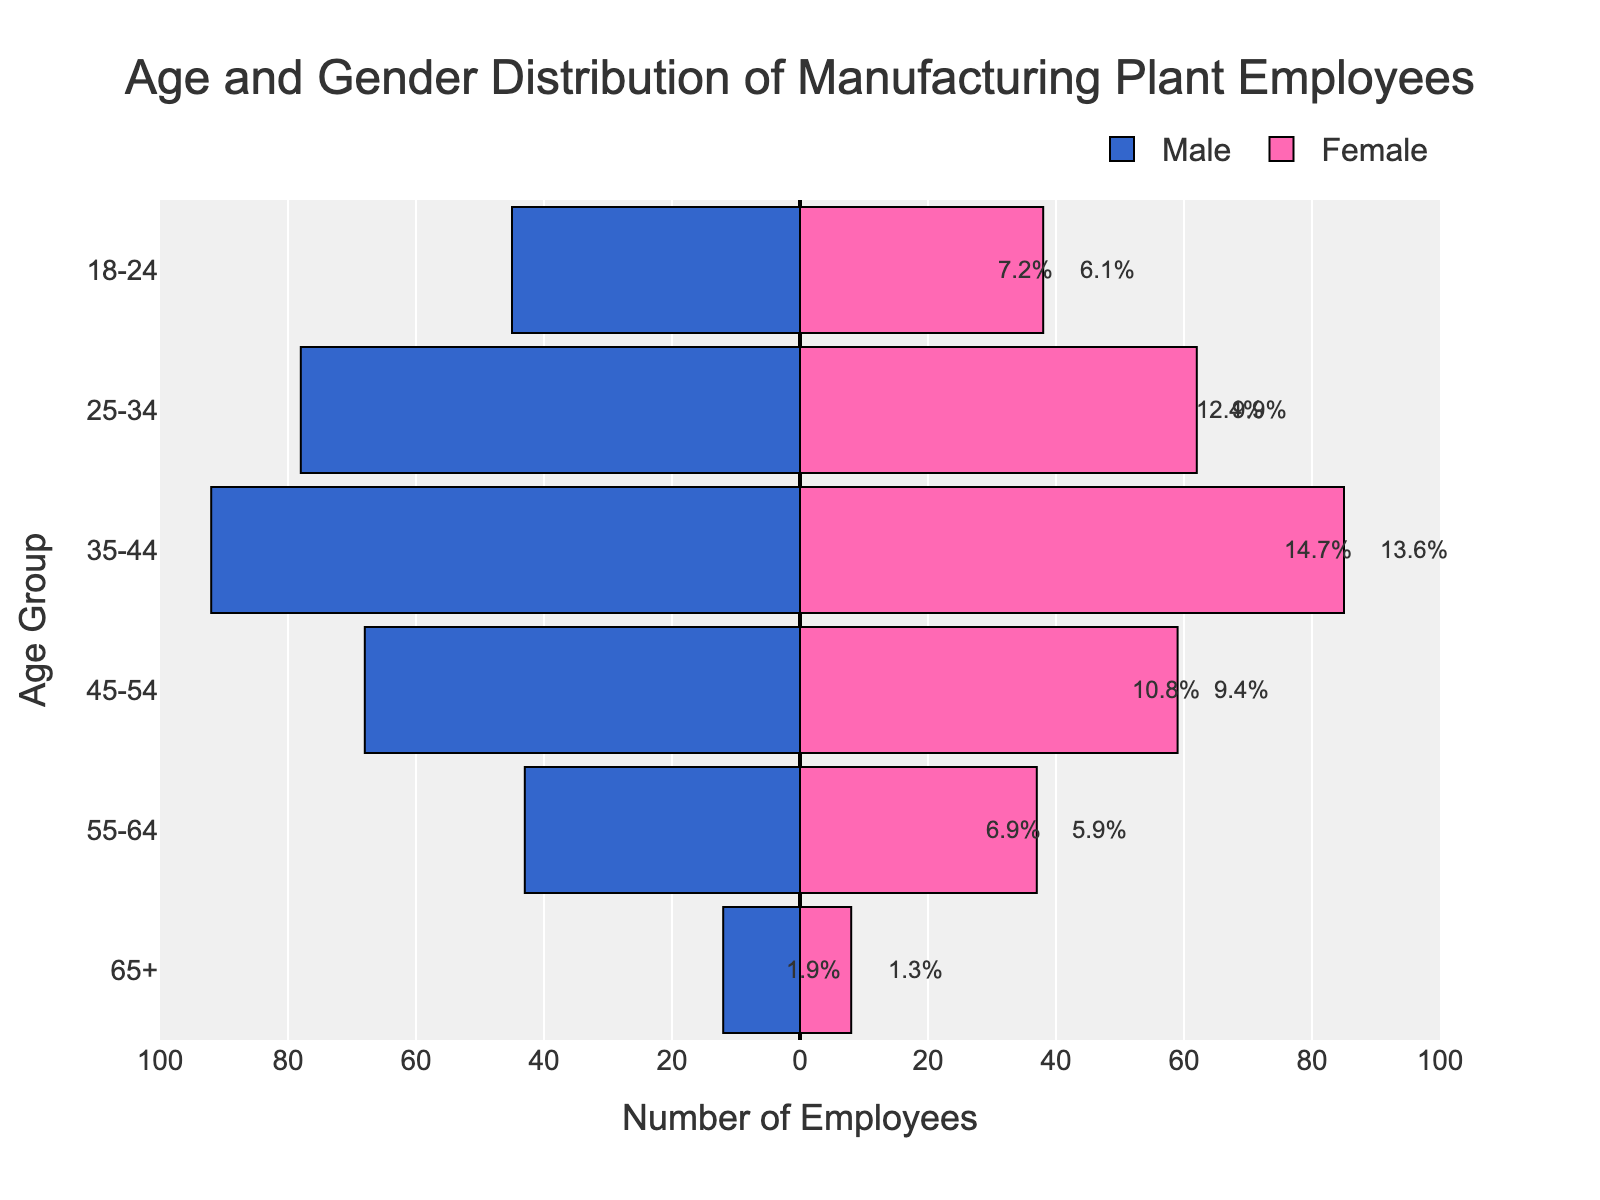What does the title of the figure indicate? The title of the figure is written at the top center of the plot and it states "Age and Gender Distribution of Manufacturing Plant Employees", indicating that the figure shows the distribution of employees by age and gender in a manufacturing plant.
Answer: Age and Gender Distribution of Manufacturing Plant Employees Which age group has the highest number of male employees? By looking at the length of the bars on the left (blue side for Male) along the x-axis, the age group "35-44" has the longest bar, indicating the highest number of male employees.
Answer: 35-44 Which age group has more female employees than male employees? None of the bars on the right (pink side for Female) exceed the corresponding bars of the same age group on the left (blue side for Male). Thus, there is no age group where the number of female employees exceeds the number of male employees.
Answer: None How many employees are there in the "25-34" age group? By summing the values of both male and female employees in the "25-34" age group from the figure: 78 males and 62 females, the total number of employees is 78 + 62.
Answer: 140 What is the range of the x-axis used in this plot? The range of the x-axis is indicated by the ticks and labels along the x-axis, which goes from -100 to 100.
Answer: -100 to 100 Which age group has the smallest number of employees in total? To find this, we compare the lengths of the bars (both male and female) for each age group. The age group "65+" has the shortest combined bars, indicating the smallest total number of employees.
Answer: 65+ How many female employees are there in the "45-54" age group? By looking at the length of the bar on the right side corresponding to "45-54" age group, the exact value is 59.
Answer: 59 What is the total percentage of employees aged "35-44"? Combine the percentage labels shown near the ends of bars for "35-44" age group: 16.6% for males and 15.4% for females, the total is 16.6% + 15.4%.
Answer: 32.0% Comparing "18-24" and "55-64", which age group has more male employees? Looking at the lengths of the bars on the left side for these age groups, "18-24" has a longer bar (45 men) compared to "55-64" (43 men).
Answer: 18-24 What is the total number of employees in the manufacturing plant? Summing up the total number of male and female employees: 45+38 + 78+62 + 92+85 + 68+59 + 43+37 + 12+8
Answer: 669 